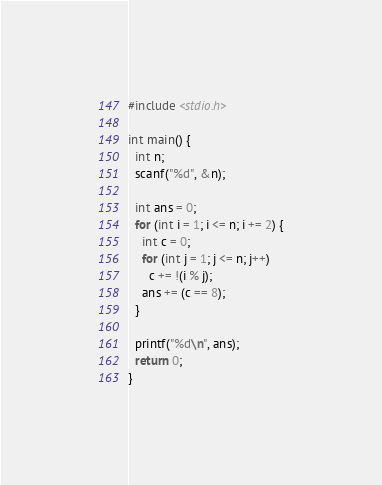Convert code to text. <code><loc_0><loc_0><loc_500><loc_500><_C_>#include <stdio.h>

int main() {
  int n;
  scanf("%d", &n);

  int ans = 0;
  for (int i = 1; i <= n; i += 2) {
    int c = 0;
    for (int j = 1; j <= n; j++)
      c += !(i % j);
    ans += (c == 8);
  }

  printf("%d\n", ans);
  return 0;
}</code> 